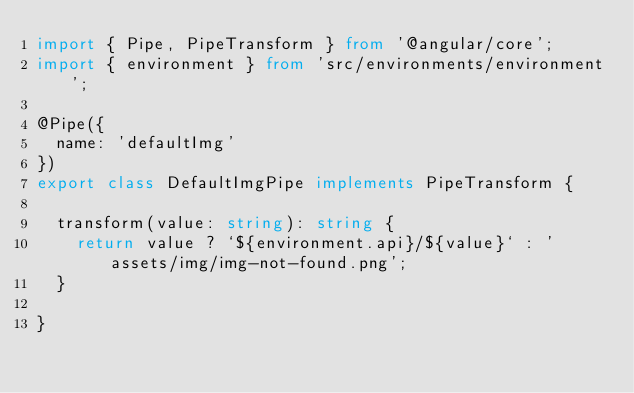<code> <loc_0><loc_0><loc_500><loc_500><_TypeScript_>import { Pipe, PipeTransform } from '@angular/core';
import { environment } from 'src/environments/environment';

@Pipe({
  name: 'defaultImg'
})
export class DefaultImgPipe implements PipeTransform {

  transform(value: string): string {
    return value ? `${environment.api}/${value}` : 'assets/img/img-not-found.png';
  }

}
</code> 